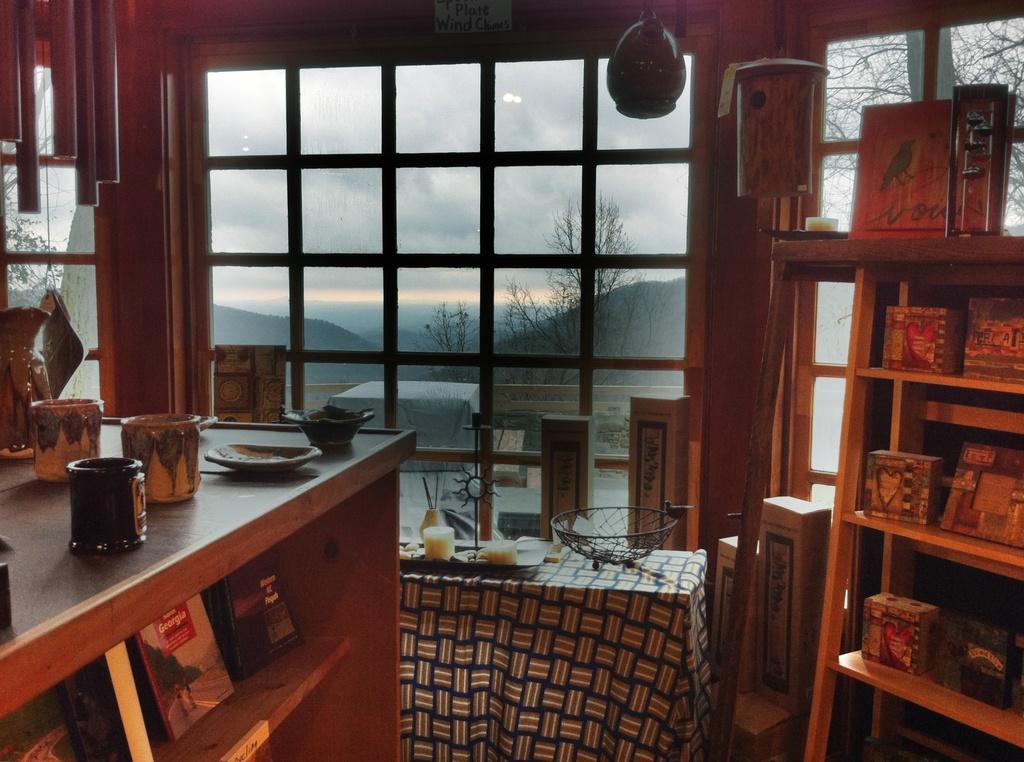In one or two sentences, can you explain what this image depicts? This picture we can see inside view of the room in which we have on the right side a wooden table with some box and frames, in front we have big glass window from there a good view of maintain and trees,on the left we can see a wooden table with some candle holder and tray. 